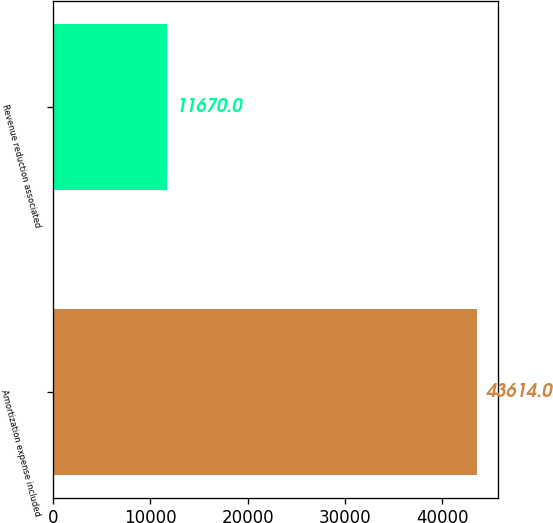<chart> <loc_0><loc_0><loc_500><loc_500><bar_chart><fcel>Amortization expense included<fcel>Revenue reduction associated<nl><fcel>43614<fcel>11670<nl></chart> 